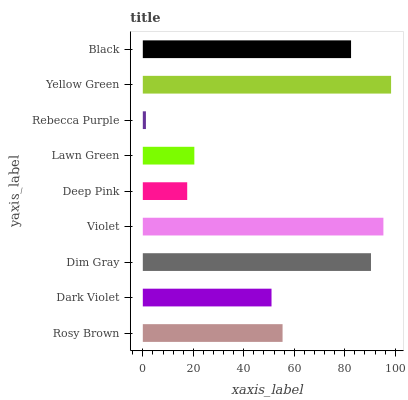Is Rebecca Purple the minimum?
Answer yes or no. Yes. Is Yellow Green the maximum?
Answer yes or no. Yes. Is Dark Violet the minimum?
Answer yes or no. No. Is Dark Violet the maximum?
Answer yes or no. No. Is Rosy Brown greater than Dark Violet?
Answer yes or no. Yes. Is Dark Violet less than Rosy Brown?
Answer yes or no. Yes. Is Dark Violet greater than Rosy Brown?
Answer yes or no. No. Is Rosy Brown less than Dark Violet?
Answer yes or no. No. Is Rosy Brown the high median?
Answer yes or no. Yes. Is Rosy Brown the low median?
Answer yes or no. Yes. Is Yellow Green the high median?
Answer yes or no. No. Is Black the low median?
Answer yes or no. No. 